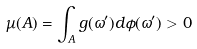<formula> <loc_0><loc_0><loc_500><loc_500>\mu ( A ) = \int _ { A } g ( \omega ^ { \prime } ) d \phi ( \omega ^ { \prime } ) > 0</formula> 